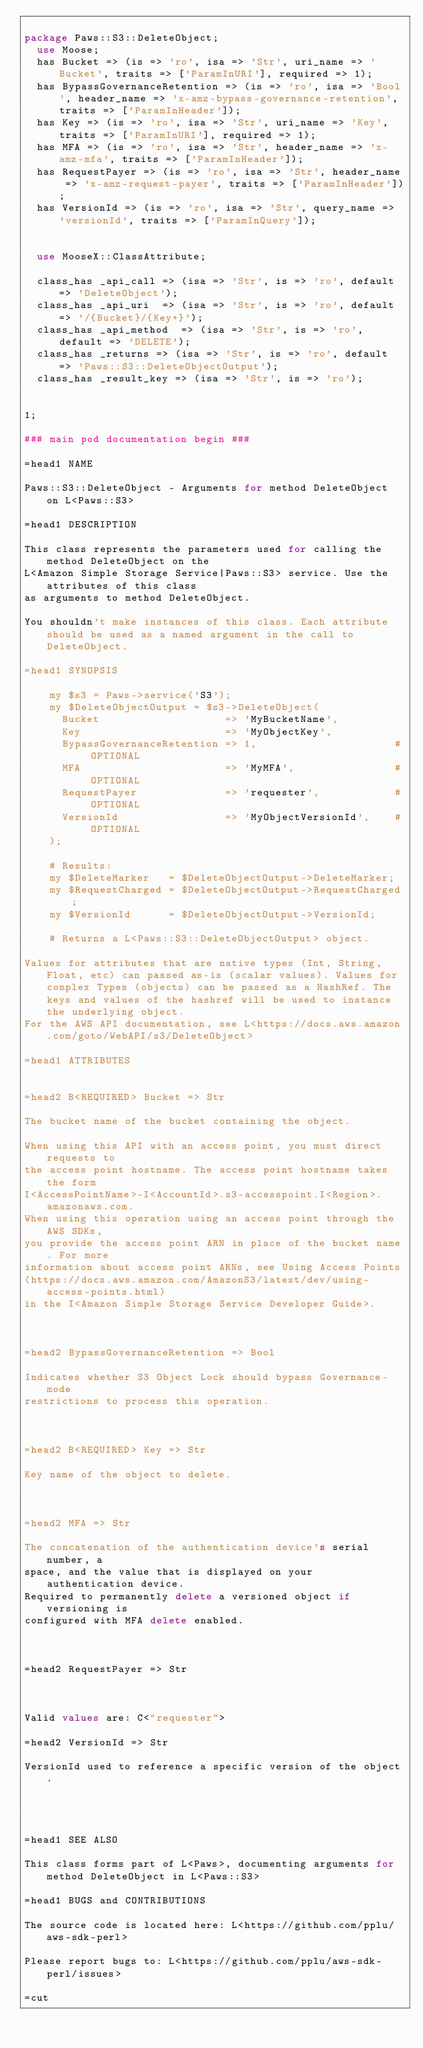<code> <loc_0><loc_0><loc_500><loc_500><_Perl_>
package Paws::S3::DeleteObject;
  use Moose;
  has Bucket => (is => 'ro', isa => 'Str', uri_name => 'Bucket', traits => ['ParamInURI'], required => 1);
  has BypassGovernanceRetention => (is => 'ro', isa => 'Bool', header_name => 'x-amz-bypass-governance-retention', traits => ['ParamInHeader']);
  has Key => (is => 'ro', isa => 'Str', uri_name => 'Key', traits => ['ParamInURI'], required => 1);
  has MFA => (is => 'ro', isa => 'Str', header_name => 'x-amz-mfa', traits => ['ParamInHeader']);
  has RequestPayer => (is => 'ro', isa => 'Str', header_name => 'x-amz-request-payer', traits => ['ParamInHeader']);
  has VersionId => (is => 'ro', isa => 'Str', query_name => 'versionId', traits => ['ParamInQuery']);


  use MooseX::ClassAttribute;

  class_has _api_call => (isa => 'Str', is => 'ro', default => 'DeleteObject');
  class_has _api_uri  => (isa => 'Str', is => 'ro', default => '/{Bucket}/{Key+}');
  class_has _api_method  => (isa => 'Str', is => 'ro', default => 'DELETE');
  class_has _returns => (isa => 'Str', is => 'ro', default => 'Paws::S3::DeleteObjectOutput');
  class_has _result_key => (isa => 'Str', is => 'ro');
  
    
1;

### main pod documentation begin ###

=head1 NAME

Paws::S3::DeleteObject - Arguments for method DeleteObject on L<Paws::S3>

=head1 DESCRIPTION

This class represents the parameters used for calling the method DeleteObject on the
L<Amazon Simple Storage Service|Paws::S3> service. Use the attributes of this class
as arguments to method DeleteObject.

You shouldn't make instances of this class. Each attribute should be used as a named argument in the call to DeleteObject.

=head1 SYNOPSIS

    my $s3 = Paws->service('S3');
    my $DeleteObjectOutput = $s3->DeleteObject(
      Bucket                    => 'MyBucketName',
      Key                       => 'MyObjectKey',
      BypassGovernanceRetention => 1,                      # OPTIONAL
      MFA                       => 'MyMFA',                # OPTIONAL
      RequestPayer              => 'requester',            # OPTIONAL
      VersionId                 => 'MyObjectVersionId',    # OPTIONAL
    );

    # Results:
    my $DeleteMarker   = $DeleteObjectOutput->DeleteMarker;
    my $RequestCharged = $DeleteObjectOutput->RequestCharged;
    my $VersionId      = $DeleteObjectOutput->VersionId;

    # Returns a L<Paws::S3::DeleteObjectOutput> object.

Values for attributes that are native types (Int, String, Float, etc) can passed as-is (scalar values). Values for complex Types (objects) can be passed as a HashRef. The keys and values of the hashref will be used to instance the underlying object.
For the AWS API documentation, see L<https://docs.aws.amazon.com/goto/WebAPI/s3/DeleteObject>

=head1 ATTRIBUTES


=head2 B<REQUIRED> Bucket => Str

The bucket name of the bucket containing the object.

When using this API with an access point, you must direct requests to
the access point hostname. The access point hostname takes the form
I<AccessPointName>-I<AccountId>.s3-accesspoint.I<Region>.amazonaws.com.
When using this operation using an access point through the AWS SDKs,
you provide the access point ARN in place of the bucket name. For more
information about access point ARNs, see Using Access Points
(https://docs.aws.amazon.com/AmazonS3/latest/dev/using-access-points.html)
in the I<Amazon Simple Storage Service Developer Guide>.



=head2 BypassGovernanceRetention => Bool

Indicates whether S3 Object Lock should bypass Governance-mode
restrictions to process this operation.



=head2 B<REQUIRED> Key => Str

Key name of the object to delete.



=head2 MFA => Str

The concatenation of the authentication device's serial number, a
space, and the value that is displayed on your authentication device.
Required to permanently delete a versioned object if versioning is
configured with MFA delete enabled.



=head2 RequestPayer => Str



Valid values are: C<"requester">

=head2 VersionId => Str

VersionId used to reference a specific version of the object.




=head1 SEE ALSO

This class forms part of L<Paws>, documenting arguments for method DeleteObject in L<Paws::S3>

=head1 BUGS and CONTRIBUTIONS

The source code is located here: L<https://github.com/pplu/aws-sdk-perl>

Please report bugs to: L<https://github.com/pplu/aws-sdk-perl/issues>

=cut

</code> 